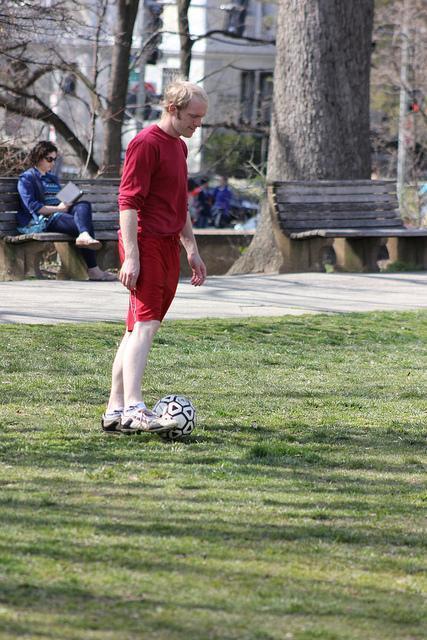How many benches are there?
Give a very brief answer. 2. How many people can you see?
Give a very brief answer. 2. 